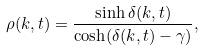Convert formula to latex. <formula><loc_0><loc_0><loc_500><loc_500>\rho ( k , t ) = \frac { \sinh \delta ( k , t ) } { \cosh ( \delta ( k , t ) - \gamma ) } ,</formula> 